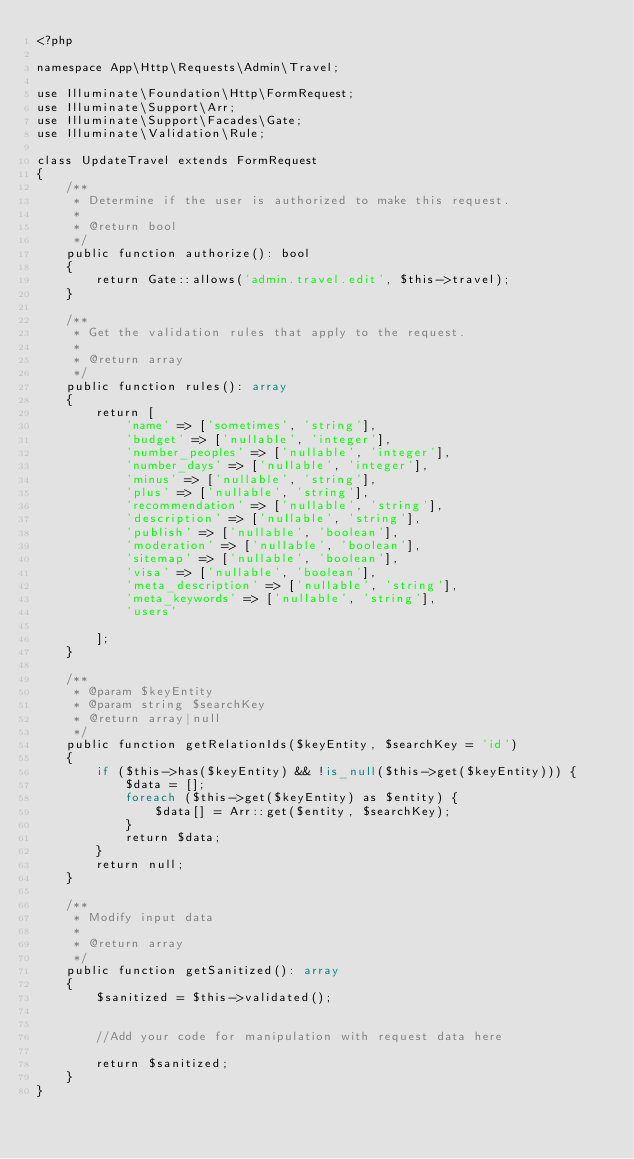<code> <loc_0><loc_0><loc_500><loc_500><_PHP_><?php

namespace App\Http\Requests\Admin\Travel;

use Illuminate\Foundation\Http\FormRequest;
use Illuminate\Support\Arr;
use Illuminate\Support\Facades\Gate;
use Illuminate\Validation\Rule;

class UpdateTravel extends FormRequest
{
    /**
     * Determine if the user is authorized to make this request.
     *
     * @return bool
     */
    public function authorize(): bool
    {
        return Gate::allows('admin.travel.edit', $this->travel);
    }

    /**
     * Get the validation rules that apply to the request.
     *
     * @return array
     */
    public function rules(): array
    {
        return [
            'name' => ['sometimes', 'string'],
            'budget' => ['nullable', 'integer'],
            'number_peoples' => ['nullable', 'integer'],
            'number_days' => ['nullable', 'integer'],
            'minus' => ['nullable', 'string'],
            'plus' => ['nullable', 'string'],
            'recommendation' => ['nullable', 'string'],
            'description' => ['nullable', 'string'],
            'publish' => ['nullable', 'boolean'],
            'moderation' => ['nullable', 'boolean'],
            'sitemap' => ['nullable', 'boolean'],
            'visa' => ['nullable', 'boolean'],
            'meta_description' => ['nullable', 'string'],
            'meta_keywords' => ['nullable', 'string'],
            'users'

        ];
    }

    /**
     * @param $keyEntity
     * @param string $searchKey
     * @return array|null
     */
    public function getRelationIds($keyEntity, $searchKey = 'id')
    {
        if ($this->has($keyEntity) && !is_null($this->get($keyEntity))) {
            $data = [];
            foreach ($this->get($keyEntity) as $entity) {
                $data[] = Arr::get($entity, $searchKey);
            }
            return $data;
        }
        return null;
    }

    /**
     * Modify input data
     *
     * @return array
     */
    public function getSanitized(): array
    {
        $sanitized = $this->validated();


        //Add your code for manipulation with request data here

        return $sanitized;
    }
}
</code> 